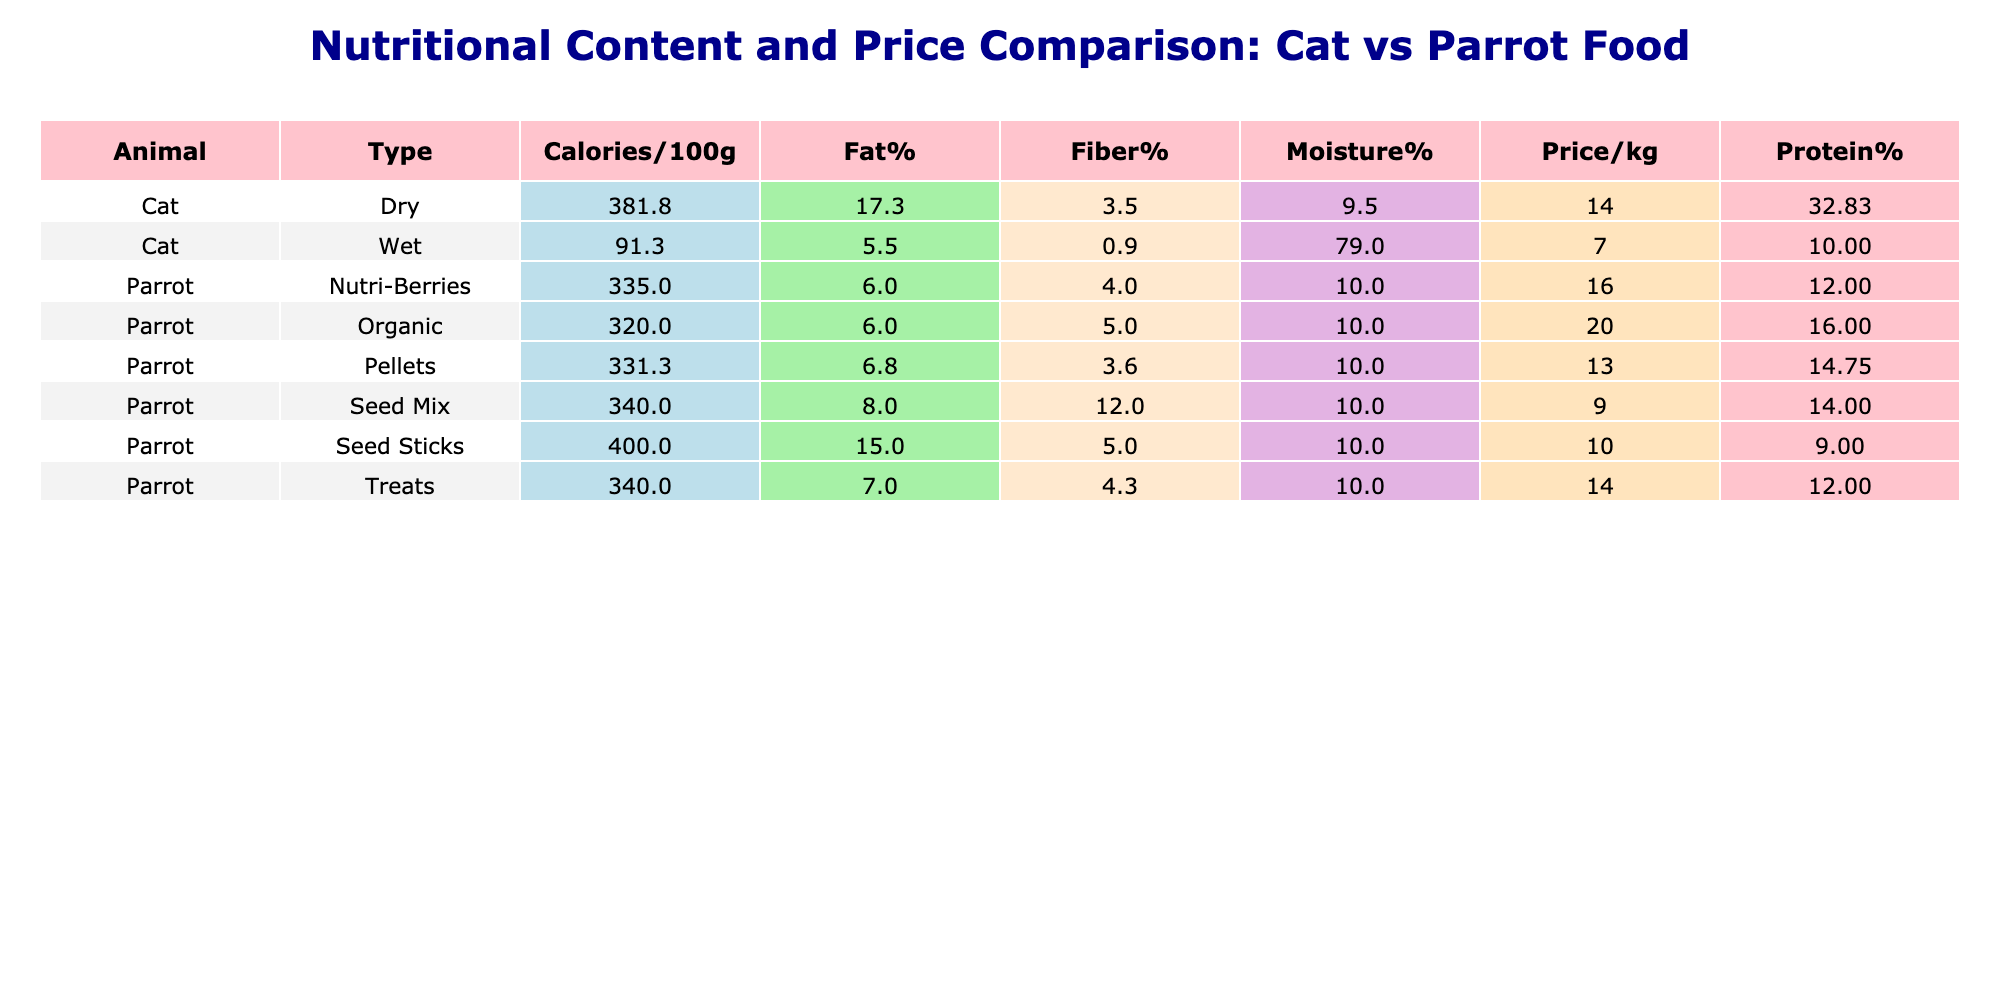What is the protein percentage of Orijen cat food? The table lists Orijen under the Cat category and its Protein% is shown directly as 40.
Answer: 40 What is the average moisture percentage in all wet cat foods? To find the average moisture percentage for wet cat foods, we need to take the moisture values: 82 (Whiskas), 78 (Purina Pro Plan), 78 (Wellness), 78 (Fancy Feast). Summing these gives: 82 + 78 + 78 + 78 = 316. There are 4 wet foods, so the average is 316 / 4 = 79.
Answer: 79 Does the parrot food by Harrison's have more protein than the food by Roudybush? Harrison's has a protein value of 16, while Roudybush has 11. Since 16 is greater than 11, we can conclude that Harrison's has more protein.
Answer: Yes What is the total fat percentage across all types of parrot foods? The fat percentage values for parrot foods are: 8 (Kaytee), 6 (ZuPreem), 6 (Harrison's), 7 (Roudybush), 6 (Lafeber), 8 (Avi-Cakes), 6 (Nutriberries), 15 (Vitakraft), 6 (Mazuri), and 8 (Pretty Bird). Summing these gives: 8 + 6 + 16 + 7 + 6 + 12 + 12 + 9 + 16 + 8 = 88.
Answer: 88 Which dry cat food has the highest calorie content? The dry cat foods are Royal Canin (373), Hill's Science Diet (395), Iams (363), Orijen (415), and Blue Buffalo (385). Comparing these values shows that Orijen has the highest calorie content at 415.
Answer: 415 What is the average price per kilogram of dry cat food? The price per kilogram values for dry cat food are: 12.99 (Royal Canin), 14.50 (Hill's Science Diet), 10.99 (Iams), 18.99 (Orijen), and 13.75 (Blue Buffalo). The sum of these is 12.99 + 14.50 + 10.99 + 18.99 + 13.75 = 70.22. To find the average: 70.22 / 5 = 14.044, rounded to two decimal places gives 14.04.
Answer: 14.04 Is the fiber percentage in Iams higher than that in Purina Pro Plan? Iams has a fiber percentage of 3, while Purina Pro Plan has 0.5. Since 3 is higher than 0.5, the statement is true.
Answer: Yes How many different types of parrot food are included in the data? There are 5 distinct types of parrot food listed: Seed Mix, Pellets, Organic, Treats, and Seed Sticks. This can be counted visually in the table.
Answer: 5 